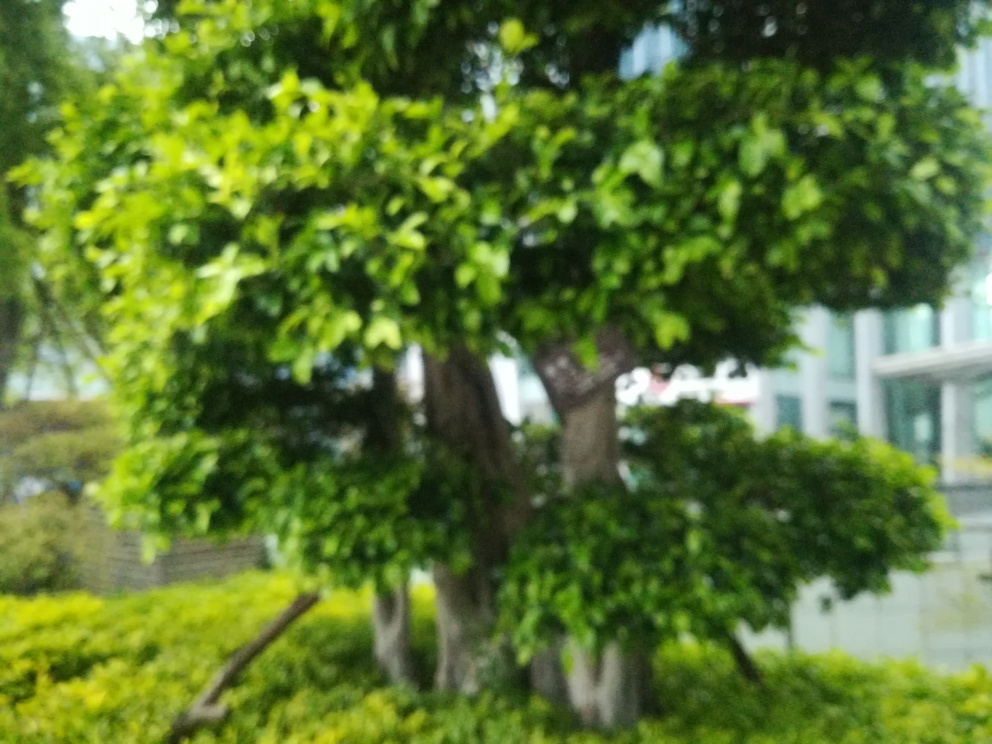Is the image lacking clarity? The photo is indeed lacking clarity, which could be due to a variety of factors such as camera shake, incorrect focus, or a dirty lens. The blurriness affects the ability to see fine details such as the texture of the tree leaves and the specific architectural features of the buildings in the background. 